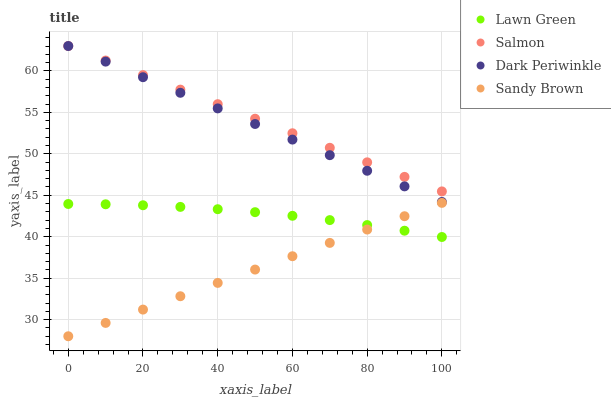Does Sandy Brown have the minimum area under the curve?
Answer yes or no. Yes. Does Salmon have the maximum area under the curve?
Answer yes or no. Yes. Does Dark Periwinkle have the minimum area under the curve?
Answer yes or no. No. Does Dark Periwinkle have the maximum area under the curve?
Answer yes or no. No. Is Salmon the smoothest?
Answer yes or no. Yes. Is Lawn Green the roughest?
Answer yes or no. Yes. Is Dark Periwinkle the smoothest?
Answer yes or no. No. Is Dark Periwinkle the roughest?
Answer yes or no. No. Does Sandy Brown have the lowest value?
Answer yes or no. Yes. Does Dark Periwinkle have the lowest value?
Answer yes or no. No. Does Dark Periwinkle have the highest value?
Answer yes or no. Yes. Does Sandy Brown have the highest value?
Answer yes or no. No. Is Sandy Brown less than Dark Periwinkle?
Answer yes or no. Yes. Is Dark Periwinkle greater than Sandy Brown?
Answer yes or no. Yes. Does Lawn Green intersect Sandy Brown?
Answer yes or no. Yes. Is Lawn Green less than Sandy Brown?
Answer yes or no. No. Is Lawn Green greater than Sandy Brown?
Answer yes or no. No. Does Sandy Brown intersect Dark Periwinkle?
Answer yes or no. No. 